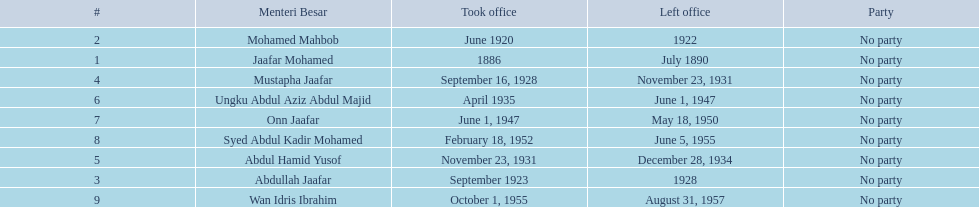Who were all of the menteri besars? Jaafar Mohamed, Mohamed Mahbob, Abdullah Jaafar, Mustapha Jaafar, Abdul Hamid Yusof, Ungku Abdul Aziz Abdul Majid, Onn Jaafar, Syed Abdul Kadir Mohamed, Wan Idris Ibrahim. When did they take office? 1886, June 1920, September 1923, September 16, 1928, November 23, 1931, April 1935, June 1, 1947, February 18, 1952, October 1, 1955. And when did they leave? July 1890, 1922, 1928, November 23, 1931, December 28, 1934, June 1, 1947, May 18, 1950, June 5, 1955, August 31, 1957. Now, who was in office for less than four years? Mohamed Mahbob. 